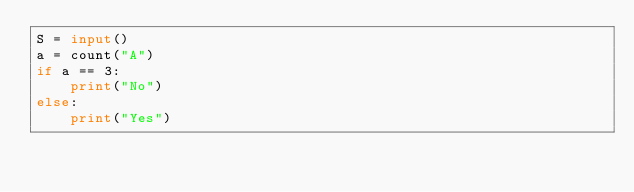Convert code to text. <code><loc_0><loc_0><loc_500><loc_500><_Python_>S = input()
a = count("A")
if a == 3:
    print("No")
else:
    print("Yes")</code> 